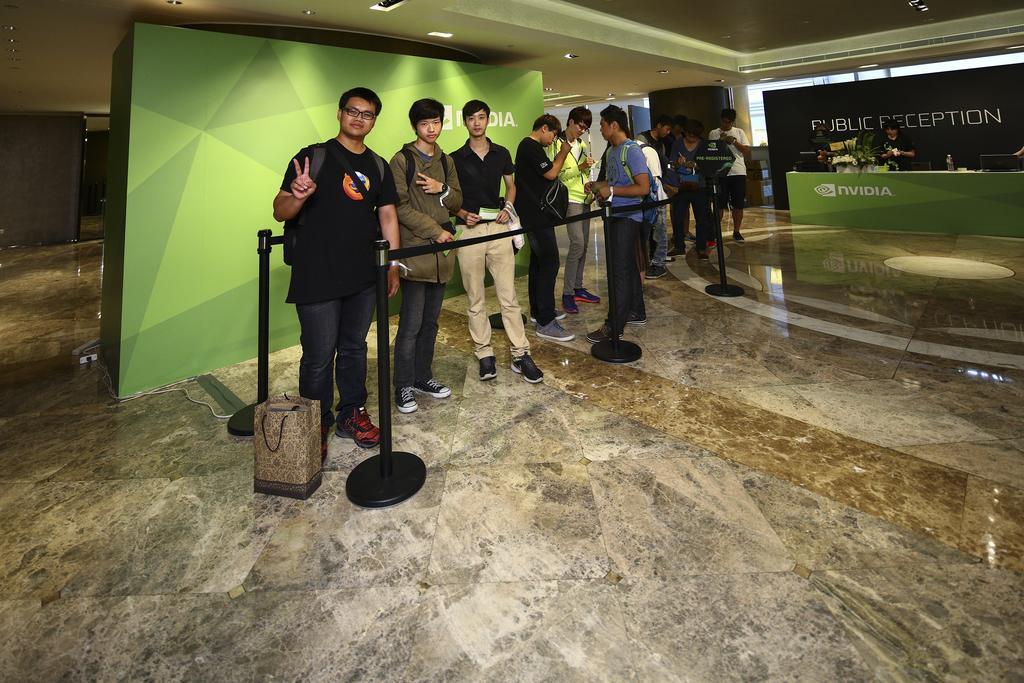Could you give a brief overview of what you see in this image? In the image we can see there are people standing, wearing clothes, shoes and some of them are wearing spectacles and carrying bag. Here we can see the floor, poster and cable wire. Here we can see paper bag, pole and barrier tape. 